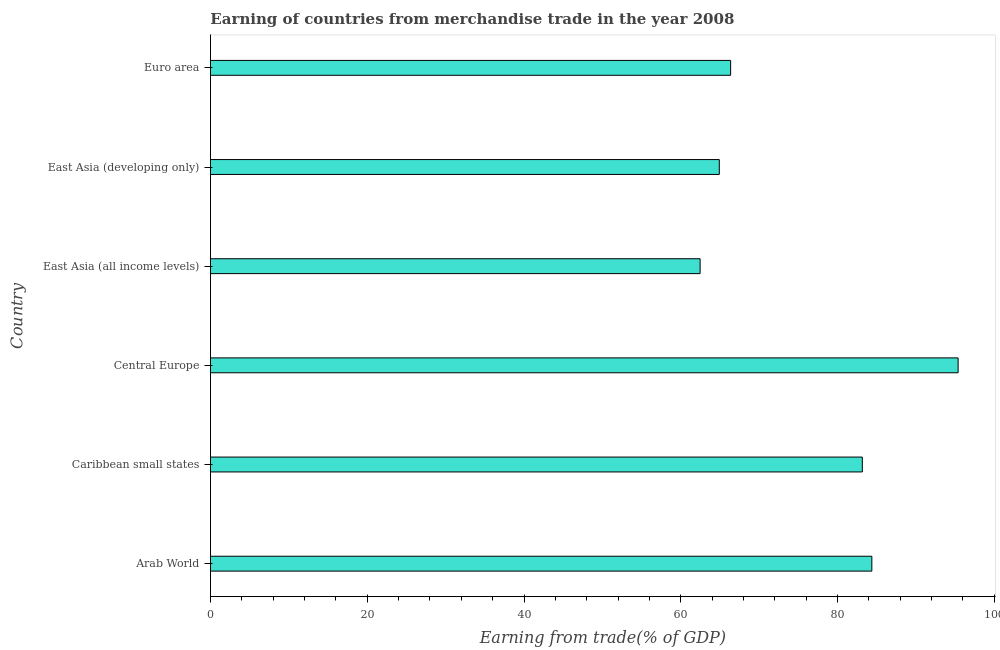Does the graph contain grids?
Make the answer very short. No. What is the title of the graph?
Your response must be concise. Earning of countries from merchandise trade in the year 2008. What is the label or title of the X-axis?
Provide a succinct answer. Earning from trade(% of GDP). What is the earning from merchandise trade in East Asia (developing only)?
Keep it short and to the point. 64.92. Across all countries, what is the maximum earning from merchandise trade?
Make the answer very short. 95.39. Across all countries, what is the minimum earning from merchandise trade?
Offer a very short reply. 62.47. In which country was the earning from merchandise trade maximum?
Offer a terse response. Central Europe. In which country was the earning from merchandise trade minimum?
Offer a very short reply. East Asia (all income levels). What is the sum of the earning from merchandise trade?
Keep it short and to the point. 456.68. What is the difference between the earning from merchandise trade in Arab World and Caribbean small states?
Make the answer very short. 1.22. What is the average earning from merchandise trade per country?
Your response must be concise. 76.11. What is the median earning from merchandise trade?
Your answer should be very brief. 74.76. In how many countries, is the earning from merchandise trade greater than 72 %?
Ensure brevity in your answer.  3. Is the earning from merchandise trade in East Asia (all income levels) less than that in Euro area?
Your answer should be very brief. Yes. What is the difference between the highest and the second highest earning from merchandise trade?
Your answer should be very brief. 11.01. What is the difference between the highest and the lowest earning from merchandise trade?
Ensure brevity in your answer.  32.92. How many bars are there?
Provide a succinct answer. 6. How many countries are there in the graph?
Your answer should be compact. 6. What is the difference between two consecutive major ticks on the X-axis?
Give a very brief answer. 20. What is the Earning from trade(% of GDP) in Arab World?
Ensure brevity in your answer.  84.38. What is the Earning from trade(% of GDP) in Caribbean small states?
Keep it short and to the point. 83.16. What is the Earning from trade(% of GDP) of Central Europe?
Keep it short and to the point. 95.39. What is the Earning from trade(% of GDP) of East Asia (all income levels)?
Offer a very short reply. 62.47. What is the Earning from trade(% of GDP) of East Asia (developing only)?
Your response must be concise. 64.92. What is the Earning from trade(% of GDP) of Euro area?
Your answer should be compact. 66.36. What is the difference between the Earning from trade(% of GDP) in Arab World and Caribbean small states?
Your answer should be compact. 1.22. What is the difference between the Earning from trade(% of GDP) in Arab World and Central Europe?
Make the answer very short. -11.01. What is the difference between the Earning from trade(% of GDP) in Arab World and East Asia (all income levels)?
Provide a succinct answer. 21.91. What is the difference between the Earning from trade(% of GDP) in Arab World and East Asia (developing only)?
Your response must be concise. 19.46. What is the difference between the Earning from trade(% of GDP) in Arab World and Euro area?
Offer a very short reply. 18.02. What is the difference between the Earning from trade(% of GDP) in Caribbean small states and Central Europe?
Offer a very short reply. -12.22. What is the difference between the Earning from trade(% of GDP) in Caribbean small states and East Asia (all income levels)?
Provide a succinct answer. 20.69. What is the difference between the Earning from trade(% of GDP) in Caribbean small states and East Asia (developing only)?
Make the answer very short. 18.25. What is the difference between the Earning from trade(% of GDP) in Caribbean small states and Euro area?
Keep it short and to the point. 16.8. What is the difference between the Earning from trade(% of GDP) in Central Europe and East Asia (all income levels)?
Provide a short and direct response. 32.92. What is the difference between the Earning from trade(% of GDP) in Central Europe and East Asia (developing only)?
Provide a short and direct response. 30.47. What is the difference between the Earning from trade(% of GDP) in Central Europe and Euro area?
Your answer should be very brief. 29.02. What is the difference between the Earning from trade(% of GDP) in East Asia (all income levels) and East Asia (developing only)?
Your answer should be compact. -2.45. What is the difference between the Earning from trade(% of GDP) in East Asia (all income levels) and Euro area?
Keep it short and to the point. -3.89. What is the difference between the Earning from trade(% of GDP) in East Asia (developing only) and Euro area?
Give a very brief answer. -1.45. What is the ratio of the Earning from trade(% of GDP) in Arab World to that in Central Europe?
Offer a terse response. 0.89. What is the ratio of the Earning from trade(% of GDP) in Arab World to that in East Asia (all income levels)?
Make the answer very short. 1.35. What is the ratio of the Earning from trade(% of GDP) in Arab World to that in East Asia (developing only)?
Give a very brief answer. 1.3. What is the ratio of the Earning from trade(% of GDP) in Arab World to that in Euro area?
Your response must be concise. 1.27. What is the ratio of the Earning from trade(% of GDP) in Caribbean small states to that in Central Europe?
Make the answer very short. 0.87. What is the ratio of the Earning from trade(% of GDP) in Caribbean small states to that in East Asia (all income levels)?
Your answer should be compact. 1.33. What is the ratio of the Earning from trade(% of GDP) in Caribbean small states to that in East Asia (developing only)?
Keep it short and to the point. 1.28. What is the ratio of the Earning from trade(% of GDP) in Caribbean small states to that in Euro area?
Provide a succinct answer. 1.25. What is the ratio of the Earning from trade(% of GDP) in Central Europe to that in East Asia (all income levels)?
Your response must be concise. 1.53. What is the ratio of the Earning from trade(% of GDP) in Central Europe to that in East Asia (developing only)?
Provide a short and direct response. 1.47. What is the ratio of the Earning from trade(% of GDP) in Central Europe to that in Euro area?
Your response must be concise. 1.44. What is the ratio of the Earning from trade(% of GDP) in East Asia (all income levels) to that in East Asia (developing only)?
Give a very brief answer. 0.96. What is the ratio of the Earning from trade(% of GDP) in East Asia (all income levels) to that in Euro area?
Provide a succinct answer. 0.94. What is the ratio of the Earning from trade(% of GDP) in East Asia (developing only) to that in Euro area?
Your answer should be very brief. 0.98. 